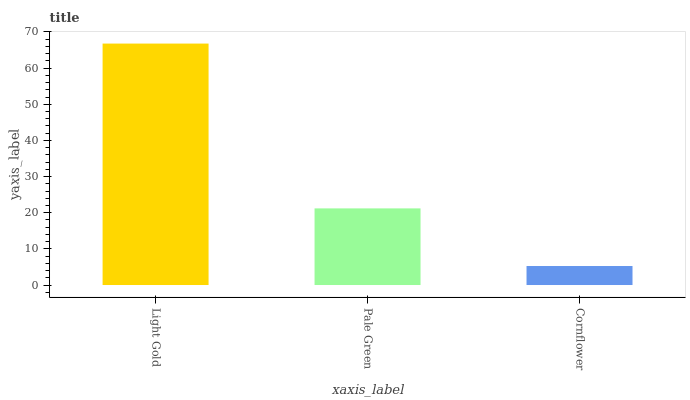Is Cornflower the minimum?
Answer yes or no. Yes. Is Light Gold the maximum?
Answer yes or no. Yes. Is Pale Green the minimum?
Answer yes or no. No. Is Pale Green the maximum?
Answer yes or no. No. Is Light Gold greater than Pale Green?
Answer yes or no. Yes. Is Pale Green less than Light Gold?
Answer yes or no. Yes. Is Pale Green greater than Light Gold?
Answer yes or no. No. Is Light Gold less than Pale Green?
Answer yes or no. No. Is Pale Green the high median?
Answer yes or no. Yes. Is Pale Green the low median?
Answer yes or no. Yes. Is Cornflower the high median?
Answer yes or no. No. Is Cornflower the low median?
Answer yes or no. No. 